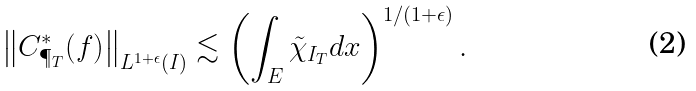<formula> <loc_0><loc_0><loc_500><loc_500>\left \| C ^ { * } _ { \P _ { T } } ( f ) \right \| _ { L ^ { 1 + \epsilon } ( I ) } \lesssim \left ( \int _ { E } \tilde { \chi } _ { I _ { T } } d x \right ) ^ { 1 / ( 1 + \epsilon ) } .</formula> 